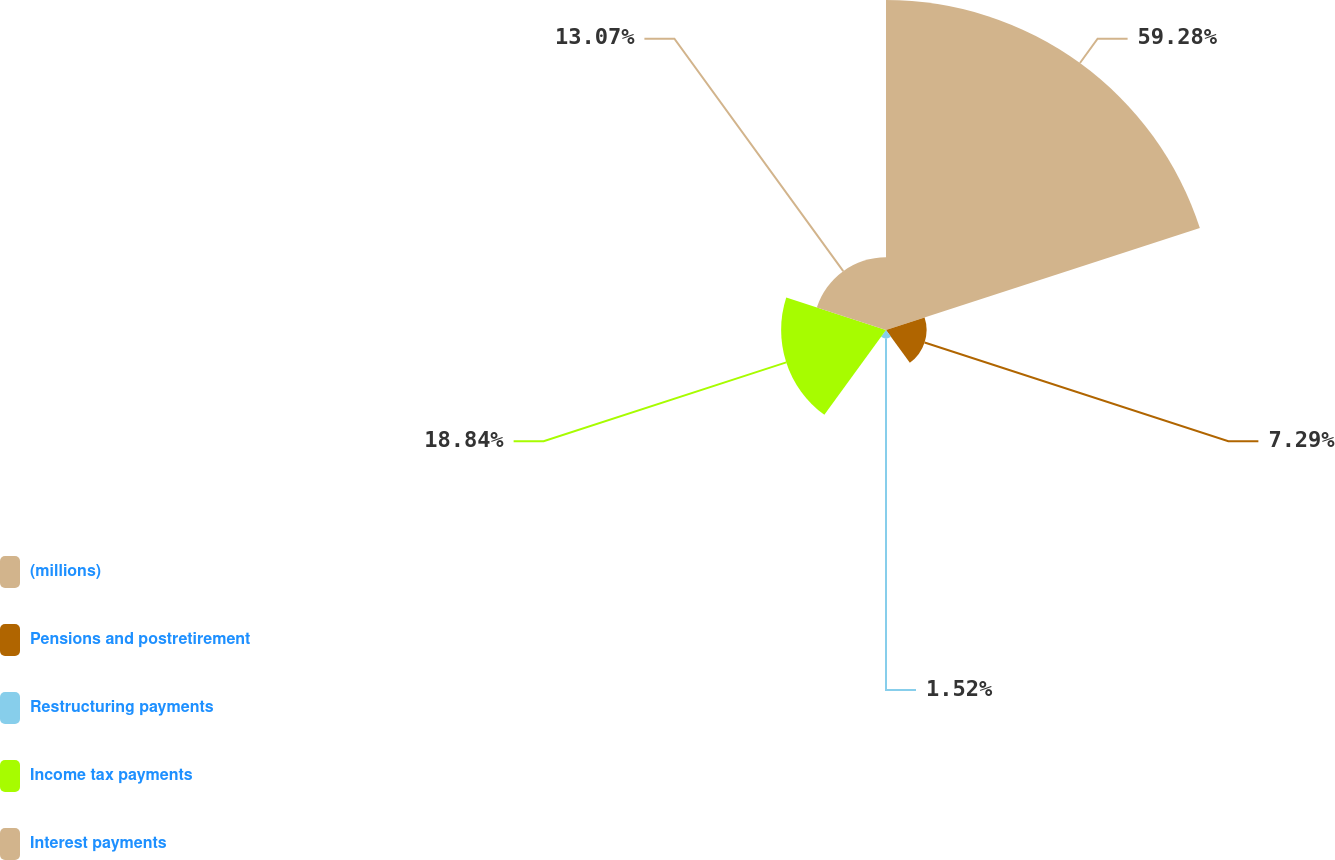Convert chart to OTSL. <chart><loc_0><loc_0><loc_500><loc_500><pie_chart><fcel>(millions)<fcel>Pensions and postretirement<fcel>Restructuring payments<fcel>Income tax payments<fcel>Interest payments<nl><fcel>59.28%<fcel>7.29%<fcel>1.52%<fcel>18.84%<fcel>13.07%<nl></chart> 